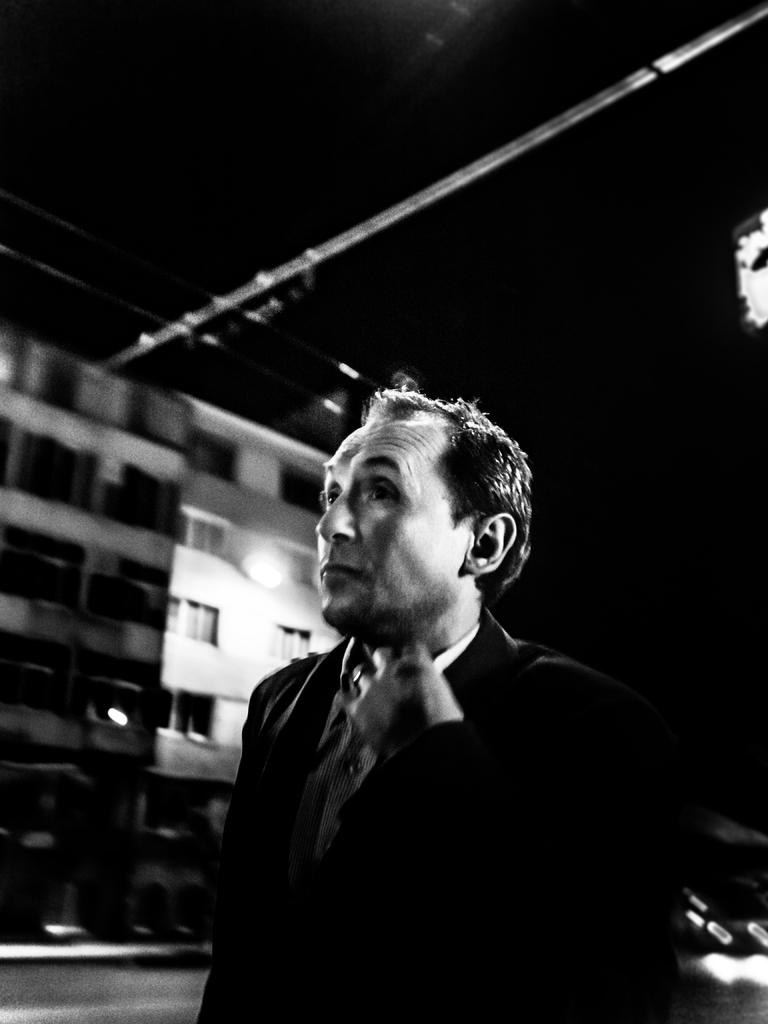Who or what is the main subject in the image? There is a person in the image. What is the person wearing? The person is wearing a black suit. What can be seen in the background of the image? There are buildings in the background of the image. Is there a boat visible in the image? No, there is no boat present in the image. What season is it in the image, considering the person's attire? The person's attire (a black suit) does not provide any information about the season. 